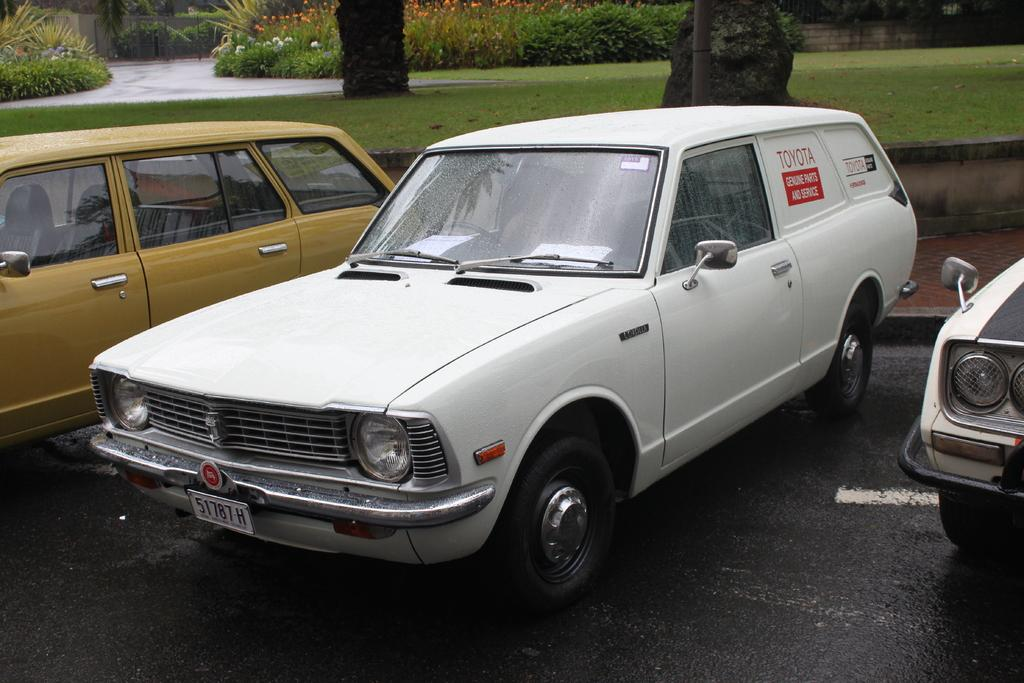What type of objects are present in the image? There are vehicles in the image. Can you describe the color of one of the vehicles? One vehicle is white in color. What can be seen in the background of the image? There are flowers and plants in the background of the image. What colors are the flowers? The flowers are orange and white in color. What color are the plants in the background? The plants in the background are green in color. What type of beef is being served in the image? There is no beef present in the image; it features vehicles and flowers in the background. Is there a gun visible in the image? There is no gun present in the image. 